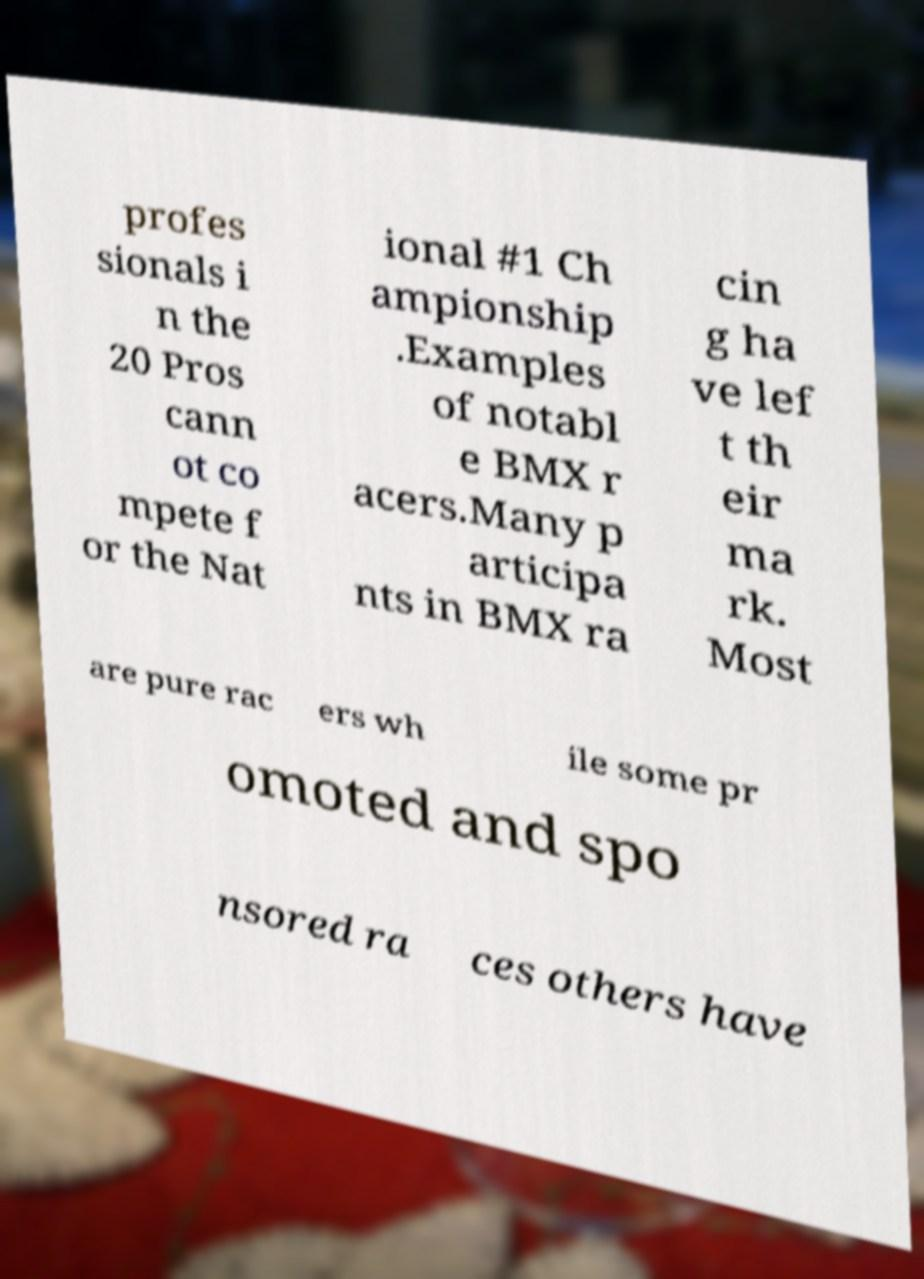Could you assist in decoding the text presented in this image and type it out clearly? profes sionals i n the 20 Pros cann ot co mpete f or the Nat ional #1 Ch ampionship .Examples of notabl e BMX r acers.Many p articipa nts in BMX ra cin g ha ve lef t th eir ma rk. Most are pure rac ers wh ile some pr omoted and spo nsored ra ces others have 